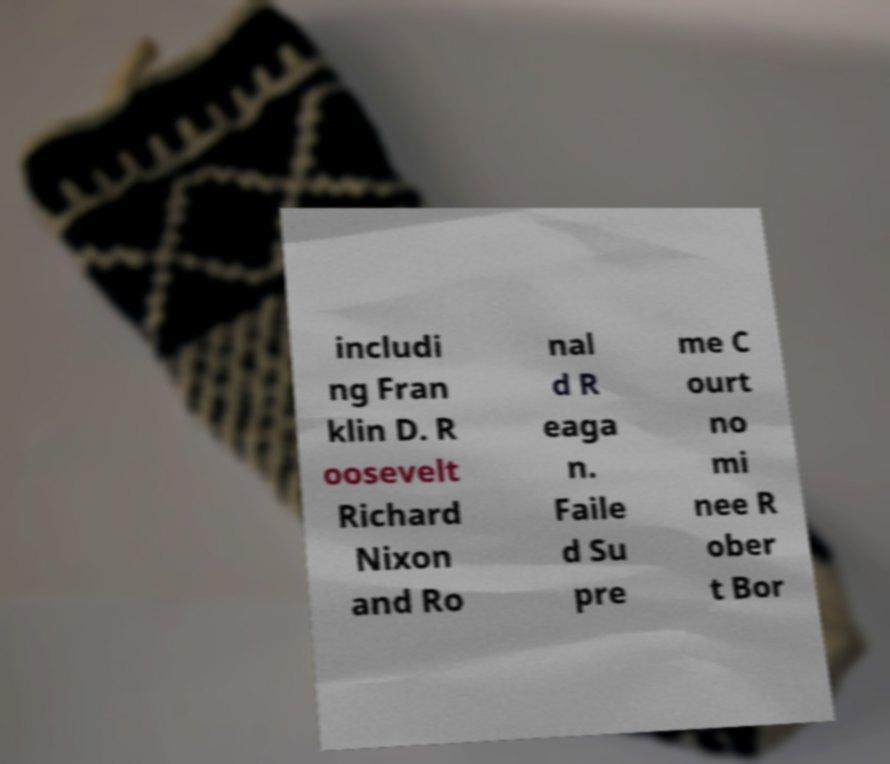Please identify and transcribe the text found in this image. includi ng Fran klin D. R oosevelt Richard Nixon and Ro nal d R eaga n. Faile d Su pre me C ourt no mi nee R ober t Bor 